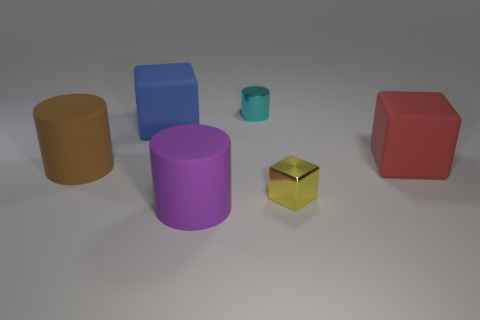Add 3 large red cylinders. How many objects exist? 9 Add 6 yellow metallic things. How many yellow metallic things are left? 7 Add 5 big green things. How many big green things exist? 5 Subtract 1 purple cylinders. How many objects are left? 5 Subtract all blue rubber things. Subtract all purple matte blocks. How many objects are left? 5 